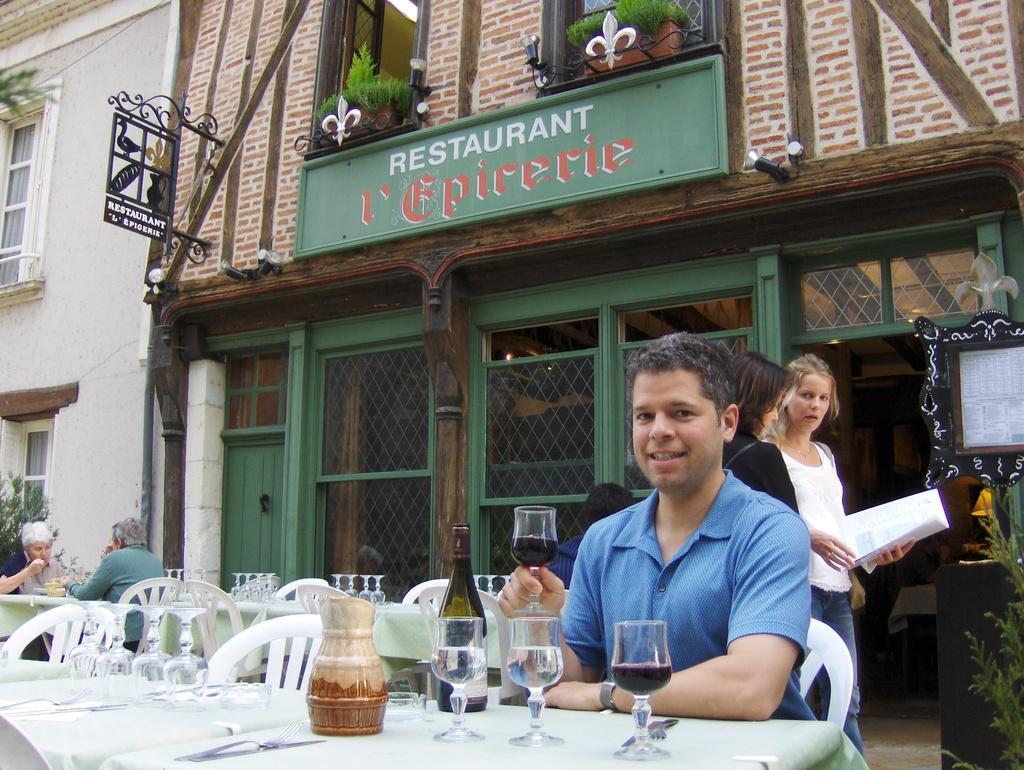How would you summarize this image in a sentence or two? This picture shows a man sitting in the chair in front of a table on which some glasses, jars were present. Behind him there are two women standing, holding a papers in their hands. In the background there is a restaurant building, windows and some plants here. 